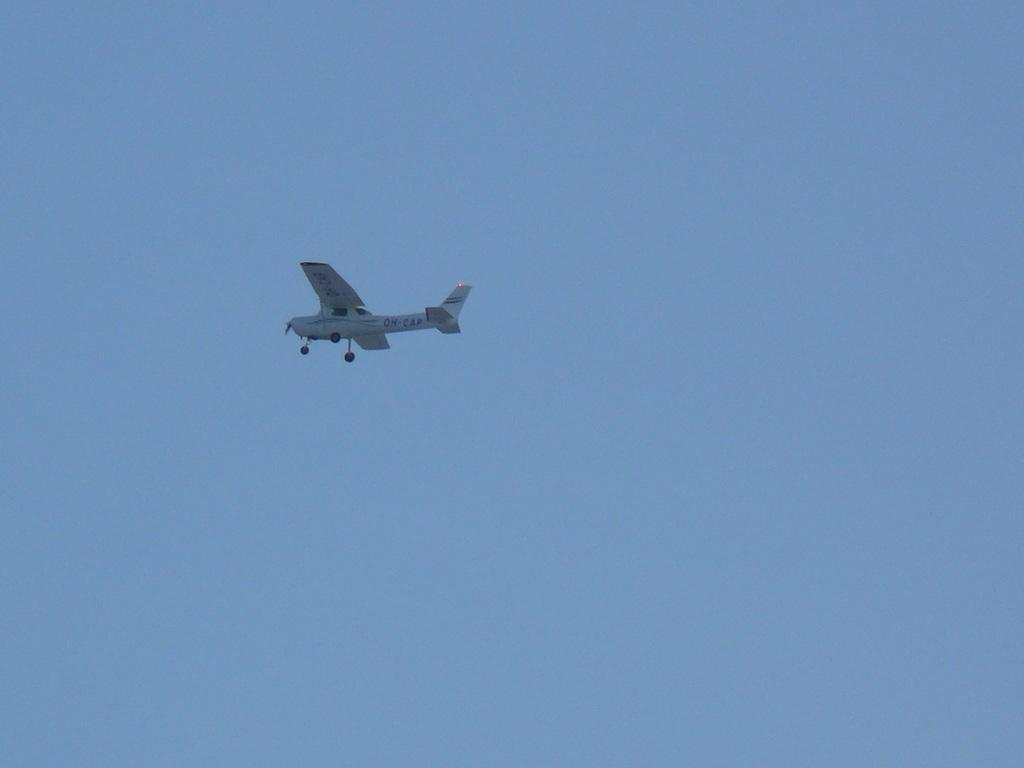What is the main subject of the image? The main subject of the image is an airplane. Where is the airplane located in the image? The airplane is in the sky. Can you tell me how many buns are visible in the image? There are no buns present in the image, as it features an airplane in the sky. What type of legal advice is the airplane seeking in the image? There is no indication in the image that the airplane is seeking legal advice, as it is simply flying in the sky. 